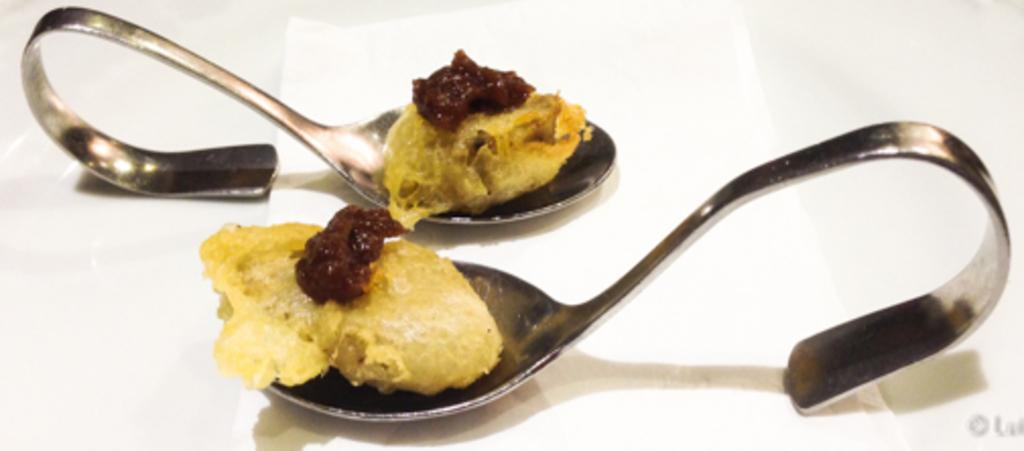What piece of furniture is present in the image? There is a table in the image. What utensils are on the table? There are two spoons on the table. What is the purpose of the spoons in the image? The spoons are holding a food item. What type of iron can be seen on the table in the image? There is no iron present on the table in the image. How can the person in the image be helped with their meal? The image does not show a person, so it is not possible to determine how they might be helped with their meal. 